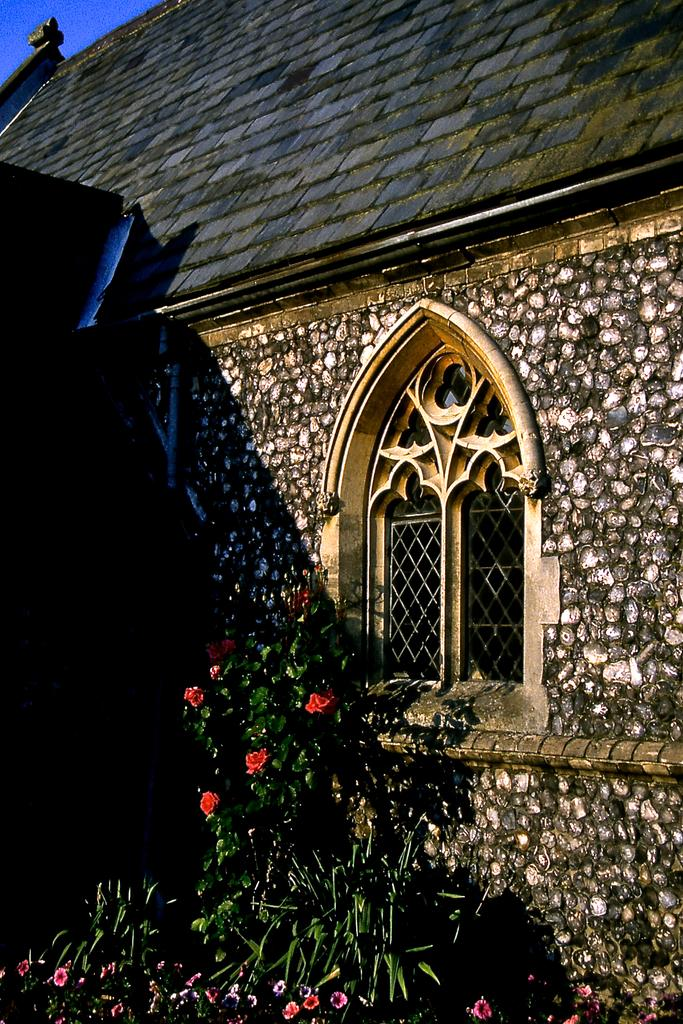What type of living organisms can be seen in the image? Plants and flowers are visible in the image. What architectural feature is present in the image? There is a window in the image. What type of outdoor space is visible in the image? There is a rooftop in the image. What is the average income of the plants in the image? There is no income associated with the plants in the image, as plants do not earn money. 